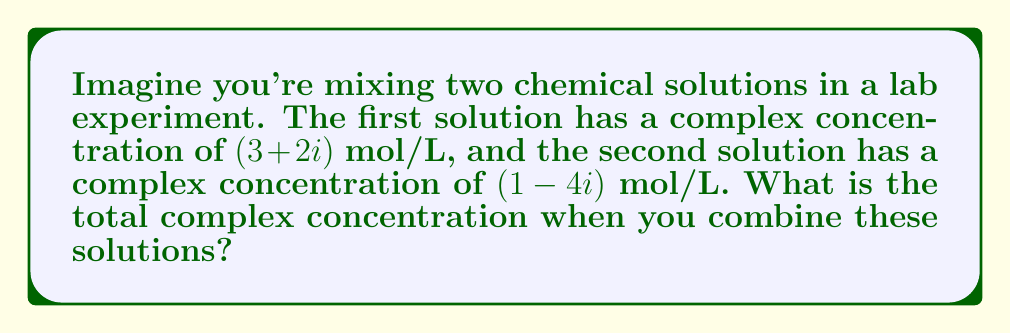Solve this math problem. Let's approach this step-by-step:

1) In this problem, we need to add two complex numbers in rectangular form.

2) The first complex number is $z_1 = 3 + 2i$
   The second complex number is $z_2 = 1 - 4i$

3) To add complex numbers in rectangular form, we add the real parts and imaginary parts separately:

   $z_1 + z_2 = (3 + 2i) + (1 - 4i)$

4) First, let's add the real parts:
   $3 + 1 = 4$

5) Now, let's add the imaginary parts:
   $2i + (-4i) = -2i$

6) Combining the results:
   $z_1 + z_2 = 4 - 2i$

This final result represents the total complex concentration of the combined solutions.
Answer: $4 - 2i$ mol/L 